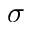<formula> <loc_0><loc_0><loc_500><loc_500>\sigma</formula> 